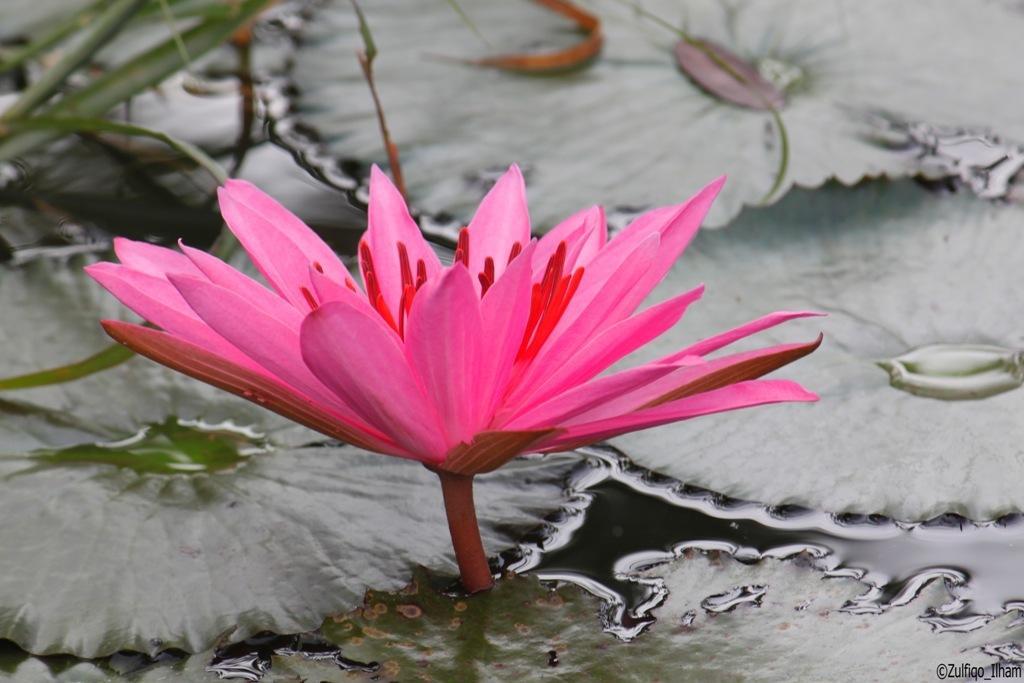Can you describe this image briefly? In the image there is a flower and under the flower there is a water surface, there are large leaves around the flower. 